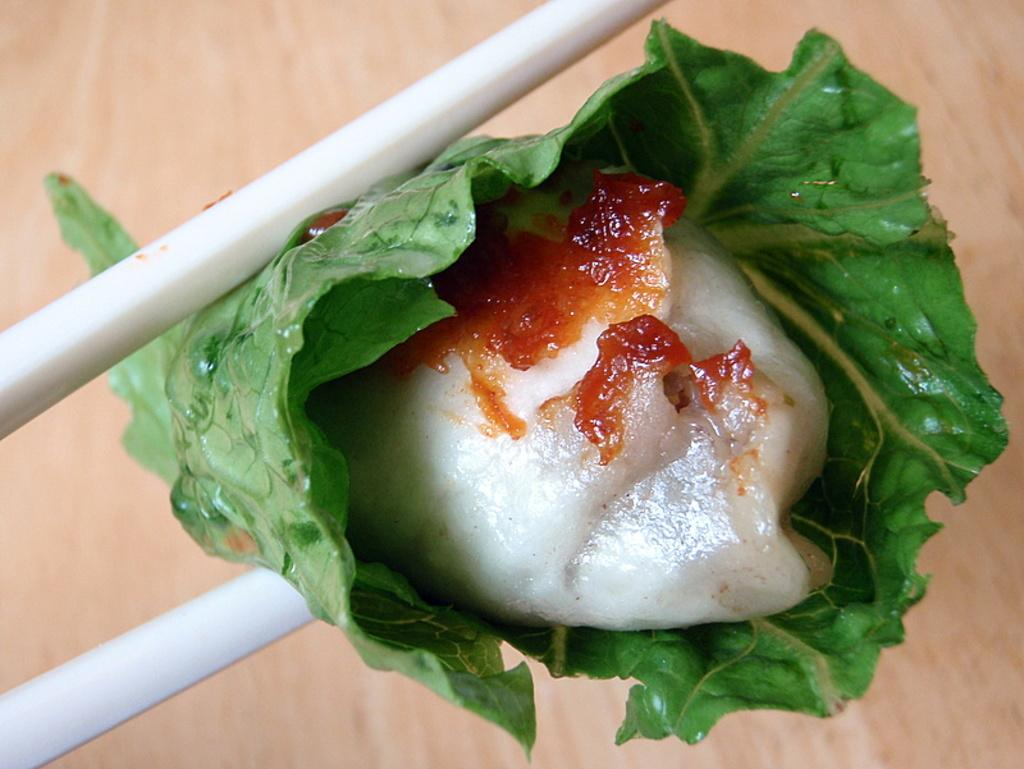What utensils are present in the image? There are two chopsticks in the image. What is the food wrapped with leafy vegetables between the chopsticks? The food wrapped with leafy vegetables is located between the chopsticks. What type of material can be seen in the background of the image? The background of the image contains wooden material. What religious symbol can be seen on the food wrapped with leafy vegetables? There is no religious symbol present on the food wrapped with leafy vegetables in the image. How many bats are visible in the image? There are no bats present in the image. 